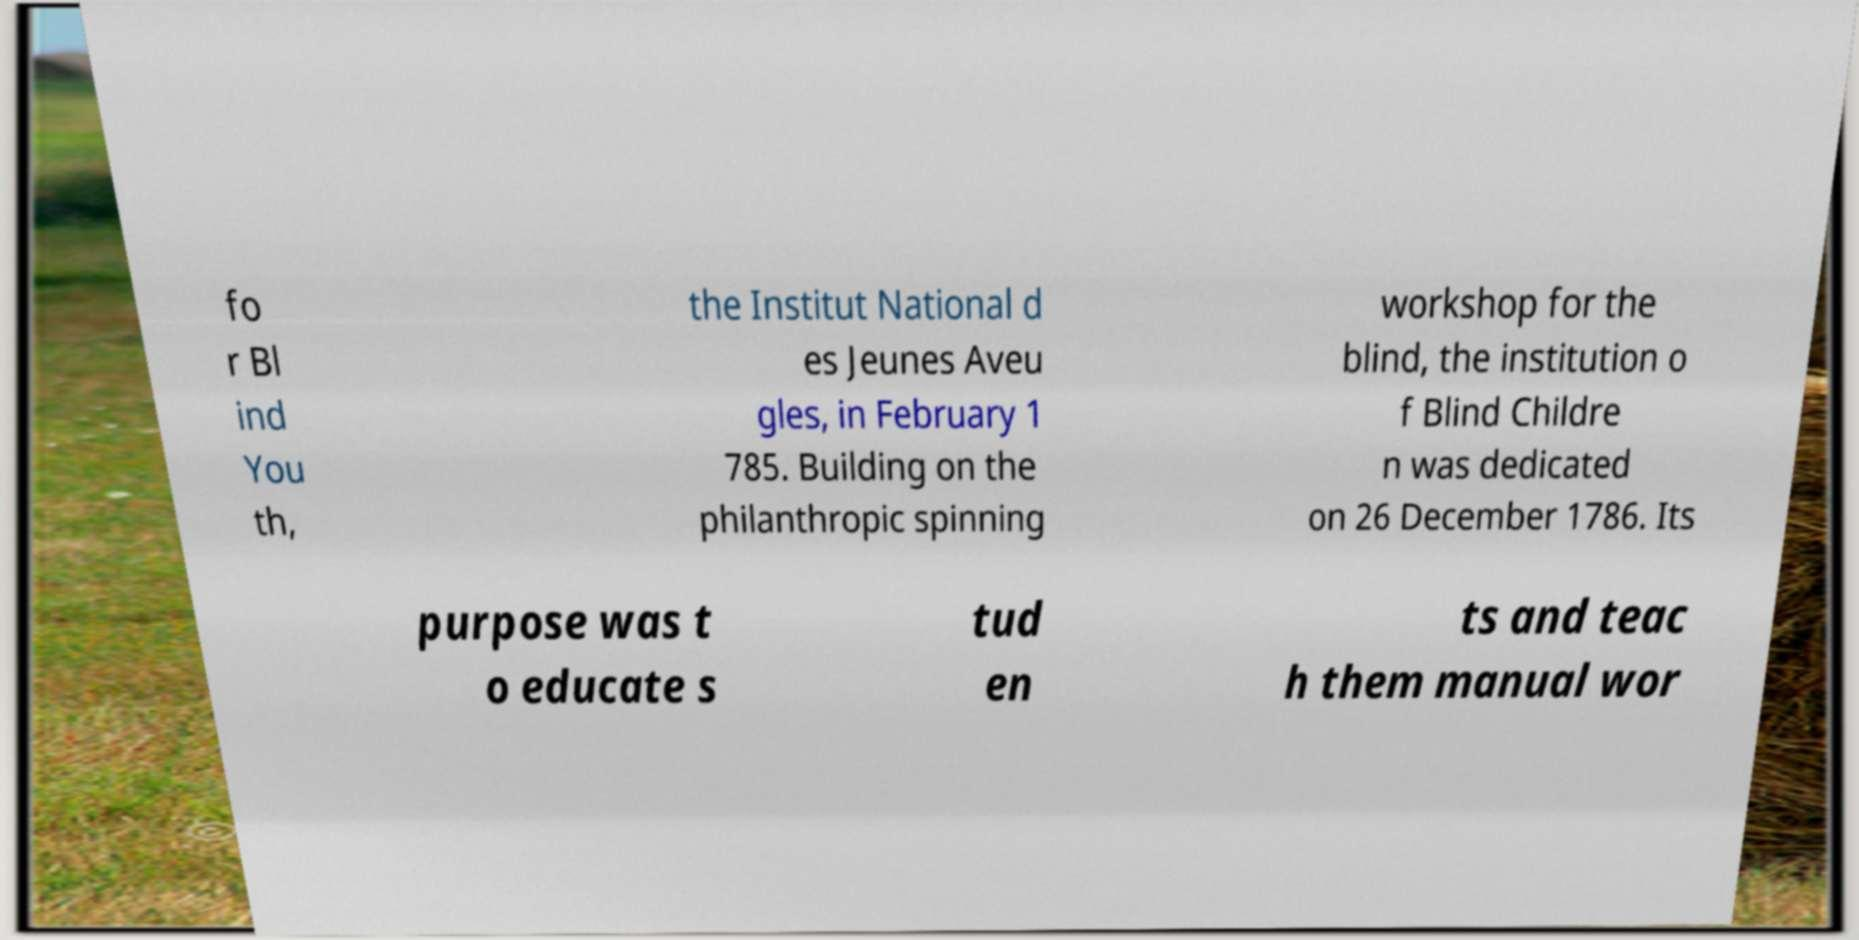Could you assist in decoding the text presented in this image and type it out clearly? fo r Bl ind You th, the Institut National d es Jeunes Aveu gles, in February 1 785. Building on the philanthropic spinning workshop for the blind, the institution o f Blind Childre n was dedicated on 26 December 1786. Its purpose was t o educate s tud en ts and teac h them manual wor 